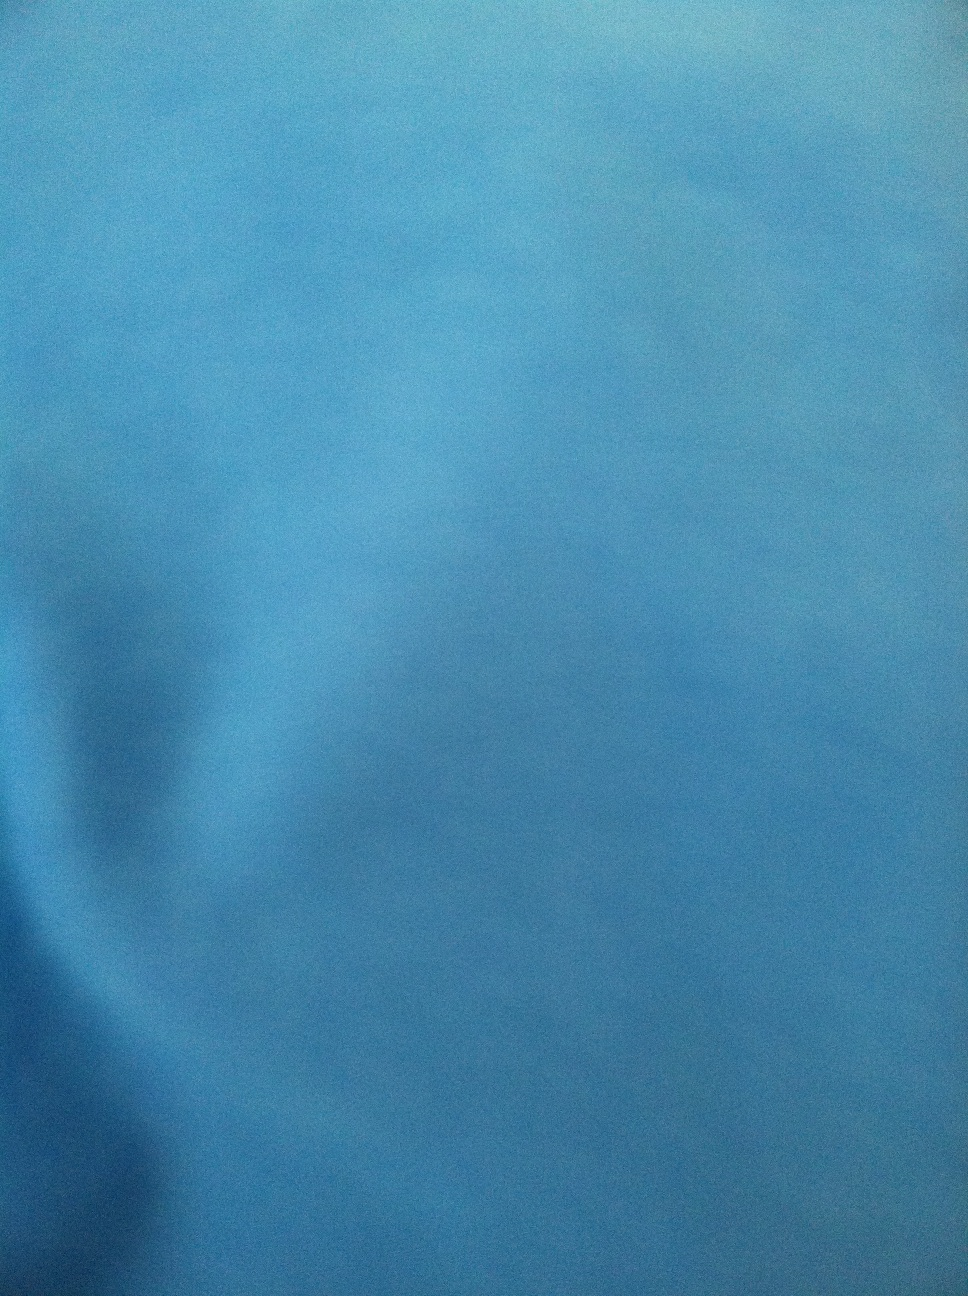Can you describe any details or patterns on the dress? The image doesn't make it easy to identify specific details or patterns, as it's quite blurred. However, the predominant color is blue without any visible distinctive patterns or other color variations. 